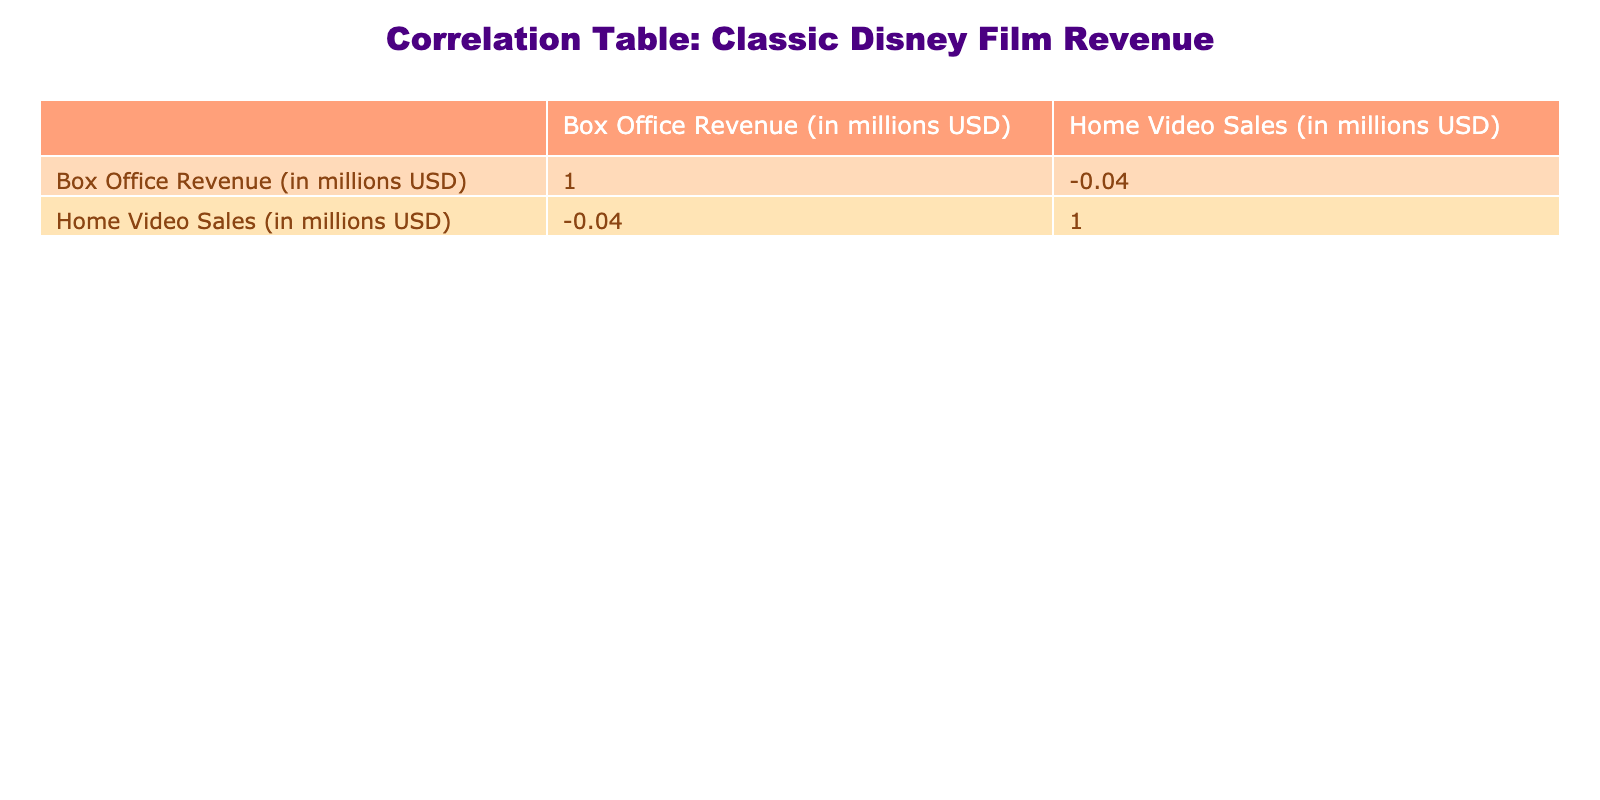What is the box office revenue for The Lion King? The box office revenue is directly listed in the table next to The Lion King, which shows a value of 968.5 million USD.
Answer: 968.5 million USD What is the home video sales figure for Aladdin? Aladdin's home video sales are listed directly in the table, showing 700 million USD next to its title.
Answer: 700 million USD Which film has the highest box office revenue? Looking at the box office revenue column, The Lion King has the highest figure at 968.5 million USD compared to the other films.
Answer: The Lion King What is the difference in home video sales between Snow White and The Little Mermaid? Snow White has home video sales of 1000 million USD, while The Little Mermaid has 300 million USD. The difference is calculated as 1000 - 300 = 700 million USD.
Answer: 700 million USD Is the home video sales for Mulan greater than that for Toy Story? Mulan has home video sales of 200 million USD and Toy Story has 600 million USD. Since 200 million is less than 600 million, the statement is false.
Answer: No What is the average box office revenue of the films listed? To find the average, we sum the box office revenues: 418.2 + 267.9 + 968.5 + 423.0 + 504.0 + 211.0 + 373.6 + 304.3 + 940.3 = 3111.8 million USD. Then, we divide by the number of films, which is 9: 3111.8 / 9 = 345.76 million USD.
Answer: 345.76 million USD Which film's home video sales are closest to the average of all home video sales? First, we can calculate the total home video sales by adding them: 1000 + 700 + 600 + 500 + 700 + 300 + 600 + 200 + 300 = 4150 million USD. The average would be 4150 / 9 = 461.11 million USD. Looking through the values, the closest value to this average is 500 million USD for Beauty and the Beast.
Answer: Beauty and the Beast Does Cinderella have more home video sales than Finding Nemo? Cinderella has home video sales of 700 million USD while Finding Nemo has 300 million USD. Since 700 million is greater than 300 million, the statement is true.
Answer: Yes What is the sum of box office revenues for films with home video sales above 500 million USD? From the table, the films with home video sales above 500 million USD are Snow White (418.2), Cinderella (267.9), Aladdin (504.0), and The Lion King (968.5). Their respective box office revenues are: 418.2 + 267.9 + 504.0 + 968.5 = 2158.6 million USD.
Answer: 2158.6 million USD 